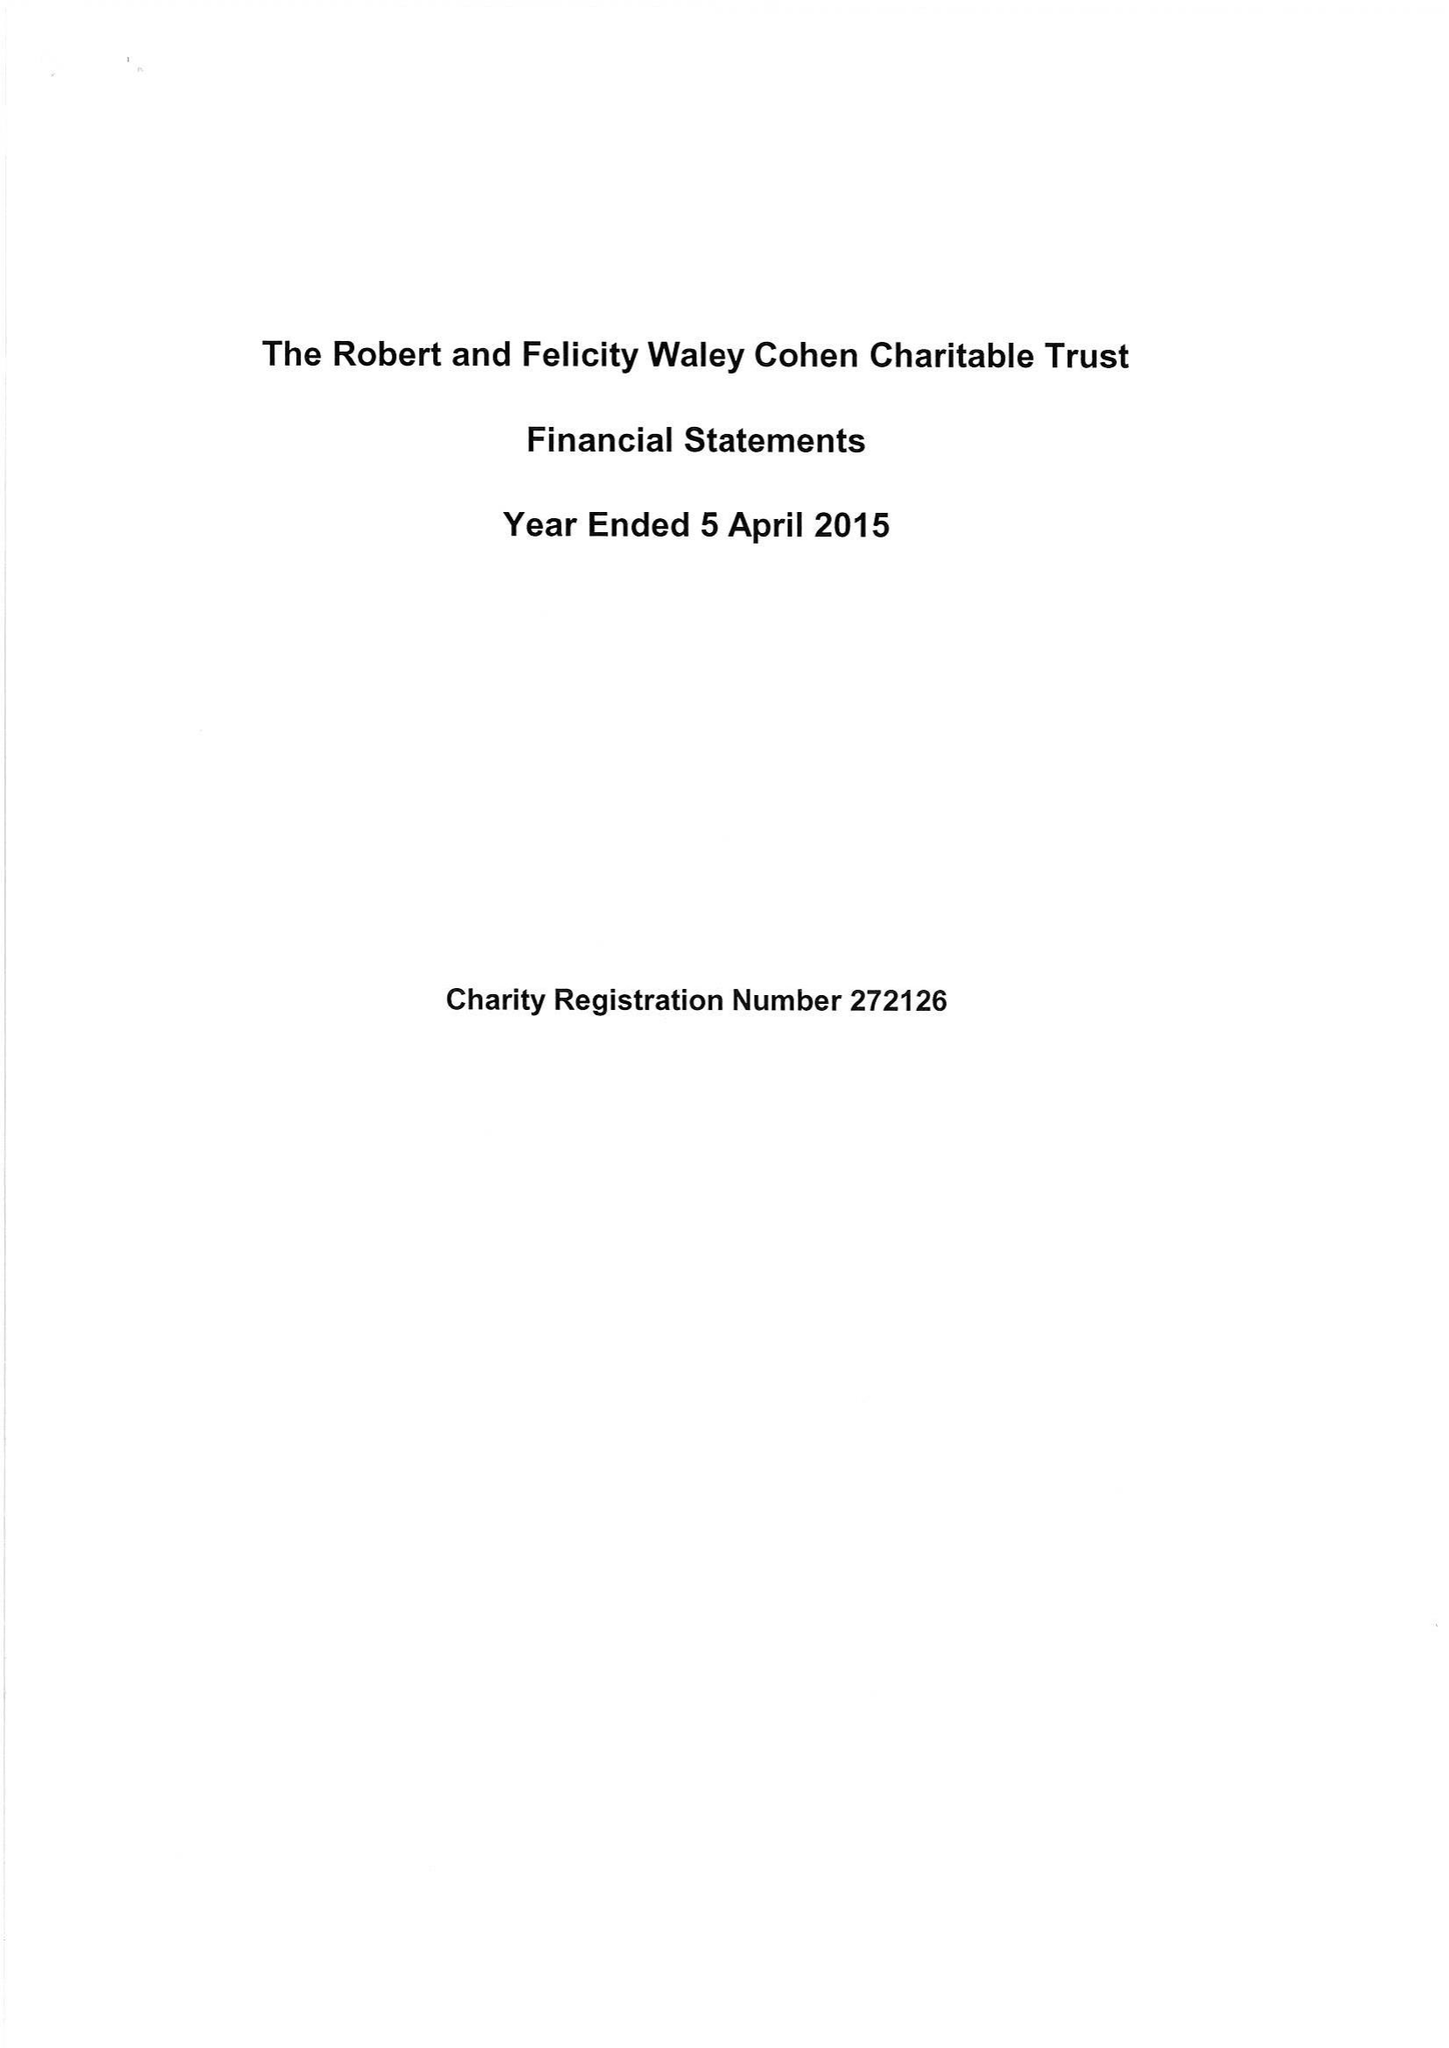What is the value for the address__postcode?
Answer the question using a single word or phrase. SW7 2TB 